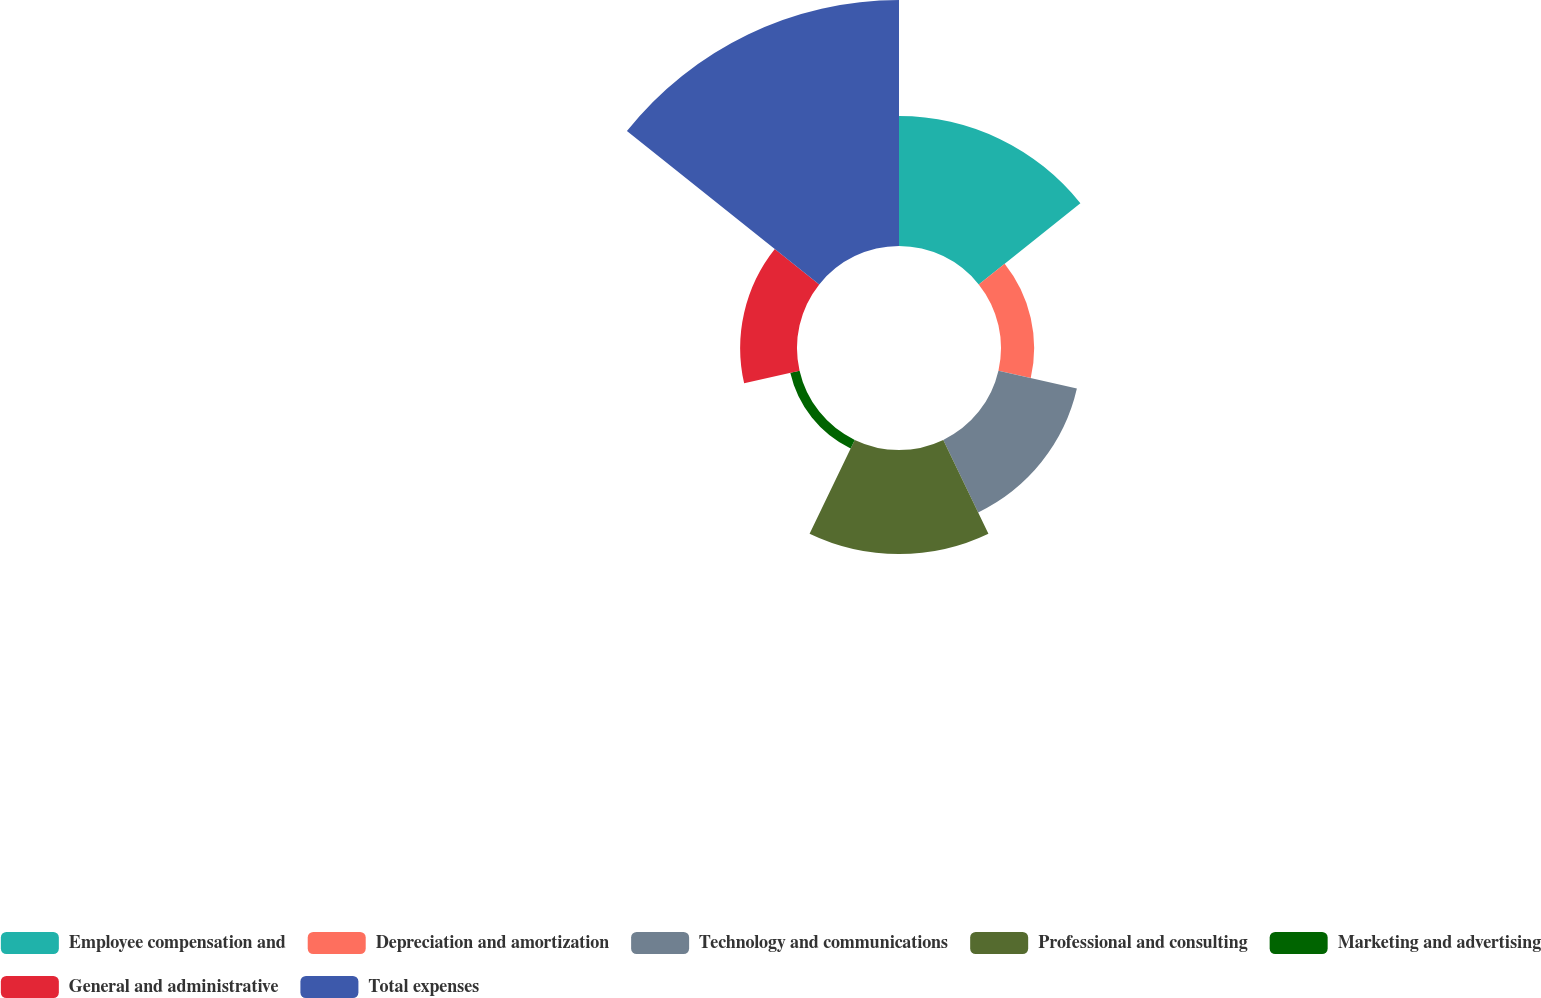Convert chart. <chart><loc_0><loc_0><loc_500><loc_500><pie_chart><fcel>Employee compensation and<fcel>Depreciation and amortization<fcel>Technology and communications<fcel>Professional and consulting<fcel>Marketing and advertising<fcel>General and administrative<fcel>Total expenses<nl><fcel>19.7%<fcel>5.02%<fcel>12.19%<fcel>15.77%<fcel>1.44%<fcel>8.61%<fcel>37.27%<nl></chart> 